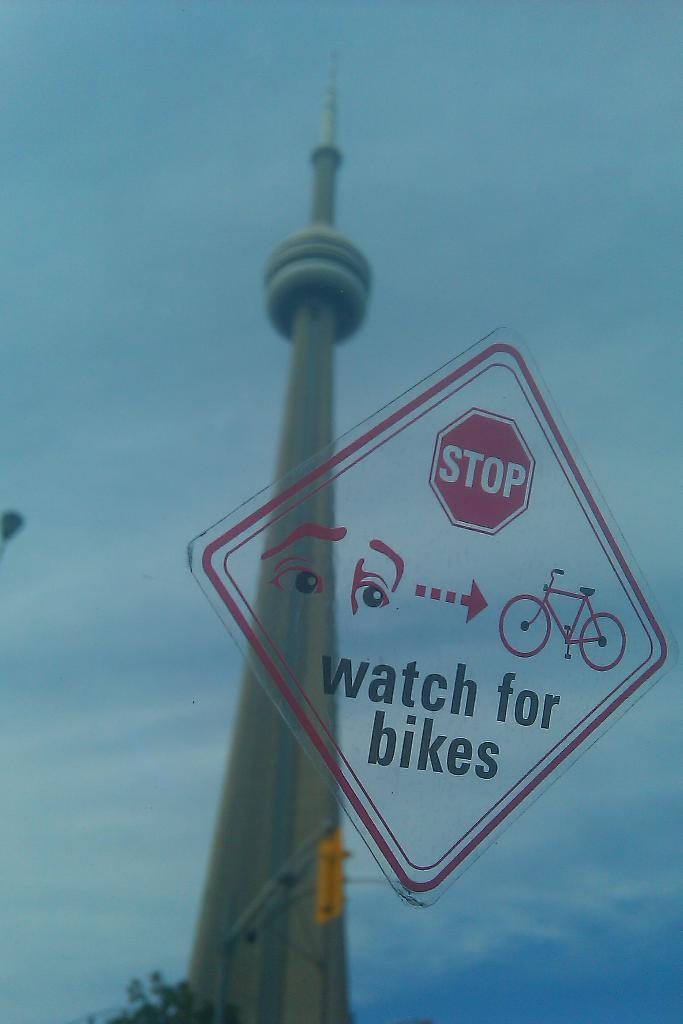<image>
Write a terse but informative summary of the picture. A stop sign tells people to watch for bikes. 